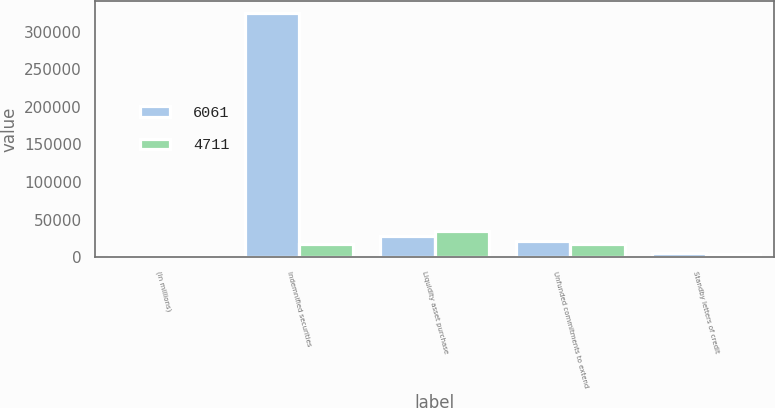<chart> <loc_0><loc_0><loc_500><loc_500><stacked_bar_chart><ecel><fcel>(In millions)<fcel>Indemnified securities<fcel>Liquidity asset purchase<fcel>Unfunded commitments to extend<fcel>Standby letters of credit<nl><fcel>6061<fcel>2008<fcel>324590<fcel>28800<fcel>20981<fcel>6061<nl><fcel>4711<fcel>2007<fcel>17533<fcel>35339<fcel>17533<fcel>4711<nl></chart> 